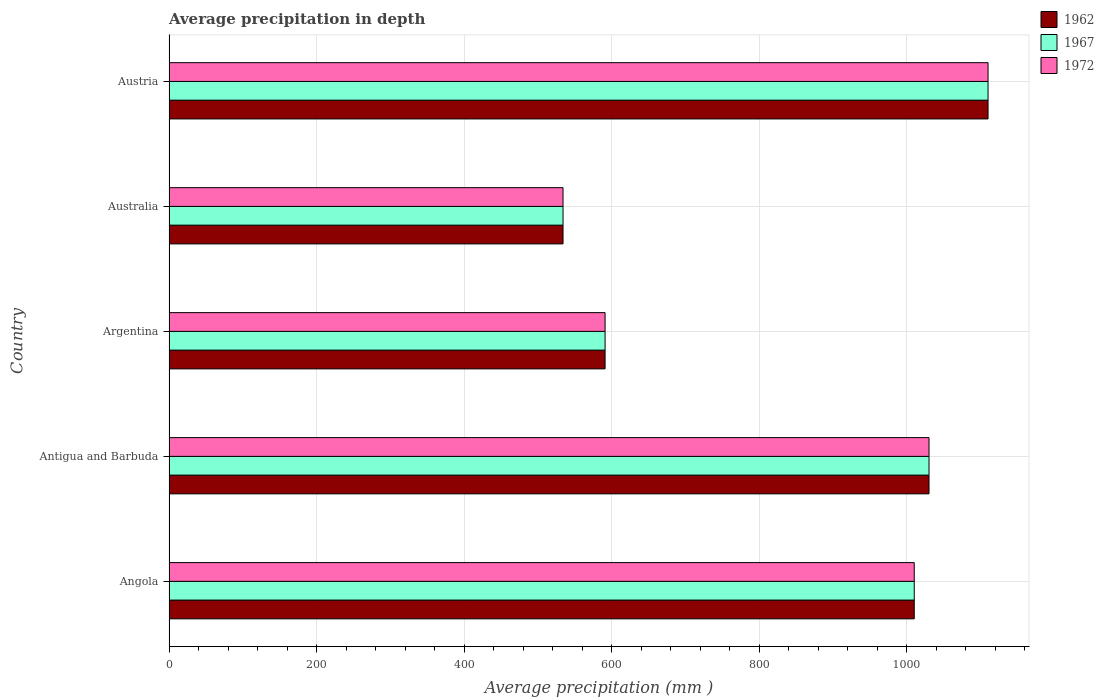Are the number of bars on each tick of the Y-axis equal?
Ensure brevity in your answer.  Yes. What is the average precipitation in 1972 in Australia?
Provide a succinct answer. 534. Across all countries, what is the maximum average precipitation in 1962?
Ensure brevity in your answer.  1110. Across all countries, what is the minimum average precipitation in 1967?
Give a very brief answer. 534. In which country was the average precipitation in 1962 minimum?
Your response must be concise. Australia. What is the total average precipitation in 1962 in the graph?
Offer a very short reply. 4275. What is the difference between the average precipitation in 1967 in Antigua and Barbuda and that in Austria?
Offer a very short reply. -80. What is the difference between the average precipitation in 1967 in Argentina and the average precipitation in 1962 in Antigua and Barbuda?
Offer a terse response. -439. What is the average average precipitation in 1967 per country?
Offer a very short reply. 855. What is the difference between the average precipitation in 1972 and average precipitation in 1967 in Austria?
Offer a very short reply. 0. What is the ratio of the average precipitation in 1967 in Antigua and Barbuda to that in Austria?
Keep it short and to the point. 0.93. What is the difference between the highest and the lowest average precipitation in 1972?
Your answer should be compact. 576. What does the 2nd bar from the bottom in Australia represents?
Offer a terse response. 1967. Is it the case that in every country, the sum of the average precipitation in 1967 and average precipitation in 1962 is greater than the average precipitation in 1972?
Offer a terse response. Yes. How many bars are there?
Your answer should be compact. 15. Are all the bars in the graph horizontal?
Your answer should be very brief. Yes. What is the difference between two consecutive major ticks on the X-axis?
Provide a short and direct response. 200. Are the values on the major ticks of X-axis written in scientific E-notation?
Provide a short and direct response. No. Does the graph contain grids?
Offer a very short reply. Yes. Where does the legend appear in the graph?
Make the answer very short. Top right. How are the legend labels stacked?
Provide a succinct answer. Vertical. What is the title of the graph?
Provide a succinct answer. Average precipitation in depth. What is the label or title of the X-axis?
Give a very brief answer. Average precipitation (mm ). What is the label or title of the Y-axis?
Offer a very short reply. Country. What is the Average precipitation (mm ) in 1962 in Angola?
Give a very brief answer. 1010. What is the Average precipitation (mm ) of 1967 in Angola?
Offer a terse response. 1010. What is the Average precipitation (mm ) in 1972 in Angola?
Offer a terse response. 1010. What is the Average precipitation (mm ) of 1962 in Antigua and Barbuda?
Offer a terse response. 1030. What is the Average precipitation (mm ) of 1967 in Antigua and Barbuda?
Ensure brevity in your answer.  1030. What is the Average precipitation (mm ) in 1972 in Antigua and Barbuda?
Provide a short and direct response. 1030. What is the Average precipitation (mm ) of 1962 in Argentina?
Provide a succinct answer. 591. What is the Average precipitation (mm ) of 1967 in Argentina?
Provide a short and direct response. 591. What is the Average precipitation (mm ) in 1972 in Argentina?
Your response must be concise. 591. What is the Average precipitation (mm ) in 1962 in Australia?
Ensure brevity in your answer.  534. What is the Average precipitation (mm ) in 1967 in Australia?
Provide a short and direct response. 534. What is the Average precipitation (mm ) in 1972 in Australia?
Keep it short and to the point. 534. What is the Average precipitation (mm ) of 1962 in Austria?
Your answer should be very brief. 1110. What is the Average precipitation (mm ) in 1967 in Austria?
Give a very brief answer. 1110. What is the Average precipitation (mm ) of 1972 in Austria?
Give a very brief answer. 1110. Across all countries, what is the maximum Average precipitation (mm ) of 1962?
Give a very brief answer. 1110. Across all countries, what is the maximum Average precipitation (mm ) of 1967?
Ensure brevity in your answer.  1110. Across all countries, what is the maximum Average precipitation (mm ) of 1972?
Give a very brief answer. 1110. Across all countries, what is the minimum Average precipitation (mm ) of 1962?
Make the answer very short. 534. Across all countries, what is the minimum Average precipitation (mm ) in 1967?
Your response must be concise. 534. Across all countries, what is the minimum Average precipitation (mm ) in 1972?
Provide a short and direct response. 534. What is the total Average precipitation (mm ) of 1962 in the graph?
Offer a very short reply. 4275. What is the total Average precipitation (mm ) of 1967 in the graph?
Keep it short and to the point. 4275. What is the total Average precipitation (mm ) of 1972 in the graph?
Provide a short and direct response. 4275. What is the difference between the Average precipitation (mm ) of 1962 in Angola and that in Antigua and Barbuda?
Offer a very short reply. -20. What is the difference between the Average precipitation (mm ) of 1967 in Angola and that in Antigua and Barbuda?
Your answer should be compact. -20. What is the difference between the Average precipitation (mm ) in 1972 in Angola and that in Antigua and Barbuda?
Offer a very short reply. -20. What is the difference between the Average precipitation (mm ) in 1962 in Angola and that in Argentina?
Give a very brief answer. 419. What is the difference between the Average precipitation (mm ) in 1967 in Angola and that in Argentina?
Your response must be concise. 419. What is the difference between the Average precipitation (mm ) of 1972 in Angola and that in Argentina?
Your answer should be very brief. 419. What is the difference between the Average precipitation (mm ) in 1962 in Angola and that in Australia?
Provide a short and direct response. 476. What is the difference between the Average precipitation (mm ) of 1967 in Angola and that in Australia?
Give a very brief answer. 476. What is the difference between the Average precipitation (mm ) of 1972 in Angola and that in Australia?
Offer a very short reply. 476. What is the difference between the Average precipitation (mm ) in 1962 in Angola and that in Austria?
Offer a very short reply. -100. What is the difference between the Average precipitation (mm ) in 1967 in Angola and that in Austria?
Ensure brevity in your answer.  -100. What is the difference between the Average precipitation (mm ) of 1972 in Angola and that in Austria?
Make the answer very short. -100. What is the difference between the Average precipitation (mm ) of 1962 in Antigua and Barbuda and that in Argentina?
Provide a short and direct response. 439. What is the difference between the Average precipitation (mm ) of 1967 in Antigua and Barbuda and that in Argentina?
Keep it short and to the point. 439. What is the difference between the Average precipitation (mm ) of 1972 in Antigua and Barbuda and that in Argentina?
Make the answer very short. 439. What is the difference between the Average precipitation (mm ) in 1962 in Antigua and Barbuda and that in Australia?
Provide a short and direct response. 496. What is the difference between the Average precipitation (mm ) in 1967 in Antigua and Barbuda and that in Australia?
Your answer should be very brief. 496. What is the difference between the Average precipitation (mm ) of 1972 in Antigua and Barbuda and that in Australia?
Offer a very short reply. 496. What is the difference between the Average precipitation (mm ) of 1962 in Antigua and Barbuda and that in Austria?
Your answer should be compact. -80. What is the difference between the Average precipitation (mm ) of 1967 in Antigua and Barbuda and that in Austria?
Ensure brevity in your answer.  -80. What is the difference between the Average precipitation (mm ) in 1972 in Antigua and Barbuda and that in Austria?
Your response must be concise. -80. What is the difference between the Average precipitation (mm ) in 1972 in Argentina and that in Australia?
Make the answer very short. 57. What is the difference between the Average precipitation (mm ) of 1962 in Argentina and that in Austria?
Offer a very short reply. -519. What is the difference between the Average precipitation (mm ) of 1967 in Argentina and that in Austria?
Provide a succinct answer. -519. What is the difference between the Average precipitation (mm ) in 1972 in Argentina and that in Austria?
Keep it short and to the point. -519. What is the difference between the Average precipitation (mm ) of 1962 in Australia and that in Austria?
Offer a very short reply. -576. What is the difference between the Average precipitation (mm ) in 1967 in Australia and that in Austria?
Provide a succinct answer. -576. What is the difference between the Average precipitation (mm ) of 1972 in Australia and that in Austria?
Make the answer very short. -576. What is the difference between the Average precipitation (mm ) of 1962 in Angola and the Average precipitation (mm ) of 1967 in Argentina?
Provide a succinct answer. 419. What is the difference between the Average precipitation (mm ) in 1962 in Angola and the Average precipitation (mm ) in 1972 in Argentina?
Offer a very short reply. 419. What is the difference between the Average precipitation (mm ) in 1967 in Angola and the Average precipitation (mm ) in 1972 in Argentina?
Make the answer very short. 419. What is the difference between the Average precipitation (mm ) in 1962 in Angola and the Average precipitation (mm ) in 1967 in Australia?
Ensure brevity in your answer.  476. What is the difference between the Average precipitation (mm ) of 1962 in Angola and the Average precipitation (mm ) of 1972 in Australia?
Offer a very short reply. 476. What is the difference between the Average precipitation (mm ) of 1967 in Angola and the Average precipitation (mm ) of 1972 in Australia?
Provide a short and direct response. 476. What is the difference between the Average precipitation (mm ) of 1962 in Angola and the Average precipitation (mm ) of 1967 in Austria?
Provide a succinct answer. -100. What is the difference between the Average precipitation (mm ) in 1962 in Angola and the Average precipitation (mm ) in 1972 in Austria?
Keep it short and to the point. -100. What is the difference between the Average precipitation (mm ) in 1967 in Angola and the Average precipitation (mm ) in 1972 in Austria?
Your response must be concise. -100. What is the difference between the Average precipitation (mm ) in 1962 in Antigua and Barbuda and the Average precipitation (mm ) in 1967 in Argentina?
Provide a succinct answer. 439. What is the difference between the Average precipitation (mm ) in 1962 in Antigua and Barbuda and the Average precipitation (mm ) in 1972 in Argentina?
Your answer should be compact. 439. What is the difference between the Average precipitation (mm ) in 1967 in Antigua and Barbuda and the Average precipitation (mm ) in 1972 in Argentina?
Give a very brief answer. 439. What is the difference between the Average precipitation (mm ) of 1962 in Antigua and Barbuda and the Average precipitation (mm ) of 1967 in Australia?
Make the answer very short. 496. What is the difference between the Average precipitation (mm ) of 1962 in Antigua and Barbuda and the Average precipitation (mm ) of 1972 in Australia?
Ensure brevity in your answer.  496. What is the difference between the Average precipitation (mm ) of 1967 in Antigua and Barbuda and the Average precipitation (mm ) of 1972 in Australia?
Keep it short and to the point. 496. What is the difference between the Average precipitation (mm ) in 1962 in Antigua and Barbuda and the Average precipitation (mm ) in 1967 in Austria?
Offer a very short reply. -80. What is the difference between the Average precipitation (mm ) of 1962 in Antigua and Barbuda and the Average precipitation (mm ) of 1972 in Austria?
Keep it short and to the point. -80. What is the difference between the Average precipitation (mm ) in 1967 in Antigua and Barbuda and the Average precipitation (mm ) in 1972 in Austria?
Provide a succinct answer. -80. What is the difference between the Average precipitation (mm ) in 1962 in Argentina and the Average precipitation (mm ) in 1967 in Austria?
Give a very brief answer. -519. What is the difference between the Average precipitation (mm ) in 1962 in Argentina and the Average precipitation (mm ) in 1972 in Austria?
Give a very brief answer. -519. What is the difference between the Average precipitation (mm ) in 1967 in Argentina and the Average precipitation (mm ) in 1972 in Austria?
Provide a short and direct response. -519. What is the difference between the Average precipitation (mm ) of 1962 in Australia and the Average precipitation (mm ) of 1967 in Austria?
Give a very brief answer. -576. What is the difference between the Average precipitation (mm ) of 1962 in Australia and the Average precipitation (mm ) of 1972 in Austria?
Keep it short and to the point. -576. What is the difference between the Average precipitation (mm ) in 1967 in Australia and the Average precipitation (mm ) in 1972 in Austria?
Ensure brevity in your answer.  -576. What is the average Average precipitation (mm ) in 1962 per country?
Keep it short and to the point. 855. What is the average Average precipitation (mm ) of 1967 per country?
Make the answer very short. 855. What is the average Average precipitation (mm ) of 1972 per country?
Offer a very short reply. 855. What is the difference between the Average precipitation (mm ) of 1962 and Average precipitation (mm ) of 1972 in Angola?
Keep it short and to the point. 0. What is the difference between the Average precipitation (mm ) of 1962 and Average precipitation (mm ) of 1967 in Antigua and Barbuda?
Keep it short and to the point. 0. What is the difference between the Average precipitation (mm ) of 1967 and Average precipitation (mm ) of 1972 in Argentina?
Your response must be concise. 0. What is the difference between the Average precipitation (mm ) of 1962 and Average precipitation (mm ) of 1967 in Australia?
Provide a short and direct response. 0. What is the difference between the Average precipitation (mm ) of 1962 and Average precipitation (mm ) of 1972 in Australia?
Your answer should be very brief. 0. What is the difference between the Average precipitation (mm ) in 1967 and Average precipitation (mm ) in 1972 in Australia?
Your answer should be compact. 0. What is the difference between the Average precipitation (mm ) of 1962 and Average precipitation (mm ) of 1972 in Austria?
Your answer should be very brief. 0. What is the ratio of the Average precipitation (mm ) of 1962 in Angola to that in Antigua and Barbuda?
Offer a very short reply. 0.98. What is the ratio of the Average precipitation (mm ) in 1967 in Angola to that in Antigua and Barbuda?
Provide a short and direct response. 0.98. What is the ratio of the Average precipitation (mm ) in 1972 in Angola to that in Antigua and Barbuda?
Your response must be concise. 0.98. What is the ratio of the Average precipitation (mm ) of 1962 in Angola to that in Argentina?
Give a very brief answer. 1.71. What is the ratio of the Average precipitation (mm ) in 1967 in Angola to that in Argentina?
Offer a very short reply. 1.71. What is the ratio of the Average precipitation (mm ) in 1972 in Angola to that in Argentina?
Give a very brief answer. 1.71. What is the ratio of the Average precipitation (mm ) of 1962 in Angola to that in Australia?
Ensure brevity in your answer.  1.89. What is the ratio of the Average precipitation (mm ) of 1967 in Angola to that in Australia?
Keep it short and to the point. 1.89. What is the ratio of the Average precipitation (mm ) in 1972 in Angola to that in Australia?
Your answer should be compact. 1.89. What is the ratio of the Average precipitation (mm ) of 1962 in Angola to that in Austria?
Provide a short and direct response. 0.91. What is the ratio of the Average precipitation (mm ) of 1967 in Angola to that in Austria?
Make the answer very short. 0.91. What is the ratio of the Average precipitation (mm ) of 1972 in Angola to that in Austria?
Your response must be concise. 0.91. What is the ratio of the Average precipitation (mm ) of 1962 in Antigua and Barbuda to that in Argentina?
Ensure brevity in your answer.  1.74. What is the ratio of the Average precipitation (mm ) of 1967 in Antigua and Barbuda to that in Argentina?
Ensure brevity in your answer.  1.74. What is the ratio of the Average precipitation (mm ) in 1972 in Antigua and Barbuda to that in Argentina?
Provide a succinct answer. 1.74. What is the ratio of the Average precipitation (mm ) in 1962 in Antigua and Barbuda to that in Australia?
Ensure brevity in your answer.  1.93. What is the ratio of the Average precipitation (mm ) in 1967 in Antigua and Barbuda to that in Australia?
Ensure brevity in your answer.  1.93. What is the ratio of the Average precipitation (mm ) in 1972 in Antigua and Barbuda to that in Australia?
Keep it short and to the point. 1.93. What is the ratio of the Average precipitation (mm ) of 1962 in Antigua and Barbuda to that in Austria?
Make the answer very short. 0.93. What is the ratio of the Average precipitation (mm ) of 1967 in Antigua and Barbuda to that in Austria?
Make the answer very short. 0.93. What is the ratio of the Average precipitation (mm ) in 1972 in Antigua and Barbuda to that in Austria?
Keep it short and to the point. 0.93. What is the ratio of the Average precipitation (mm ) in 1962 in Argentina to that in Australia?
Make the answer very short. 1.11. What is the ratio of the Average precipitation (mm ) of 1967 in Argentina to that in Australia?
Ensure brevity in your answer.  1.11. What is the ratio of the Average precipitation (mm ) in 1972 in Argentina to that in Australia?
Your response must be concise. 1.11. What is the ratio of the Average precipitation (mm ) in 1962 in Argentina to that in Austria?
Provide a succinct answer. 0.53. What is the ratio of the Average precipitation (mm ) of 1967 in Argentina to that in Austria?
Your answer should be compact. 0.53. What is the ratio of the Average precipitation (mm ) in 1972 in Argentina to that in Austria?
Give a very brief answer. 0.53. What is the ratio of the Average precipitation (mm ) in 1962 in Australia to that in Austria?
Offer a terse response. 0.48. What is the ratio of the Average precipitation (mm ) in 1967 in Australia to that in Austria?
Your response must be concise. 0.48. What is the ratio of the Average precipitation (mm ) of 1972 in Australia to that in Austria?
Keep it short and to the point. 0.48. What is the difference between the highest and the second highest Average precipitation (mm ) of 1962?
Offer a terse response. 80. What is the difference between the highest and the second highest Average precipitation (mm ) in 1967?
Offer a terse response. 80. What is the difference between the highest and the lowest Average precipitation (mm ) of 1962?
Make the answer very short. 576. What is the difference between the highest and the lowest Average precipitation (mm ) in 1967?
Keep it short and to the point. 576. What is the difference between the highest and the lowest Average precipitation (mm ) in 1972?
Your answer should be very brief. 576. 